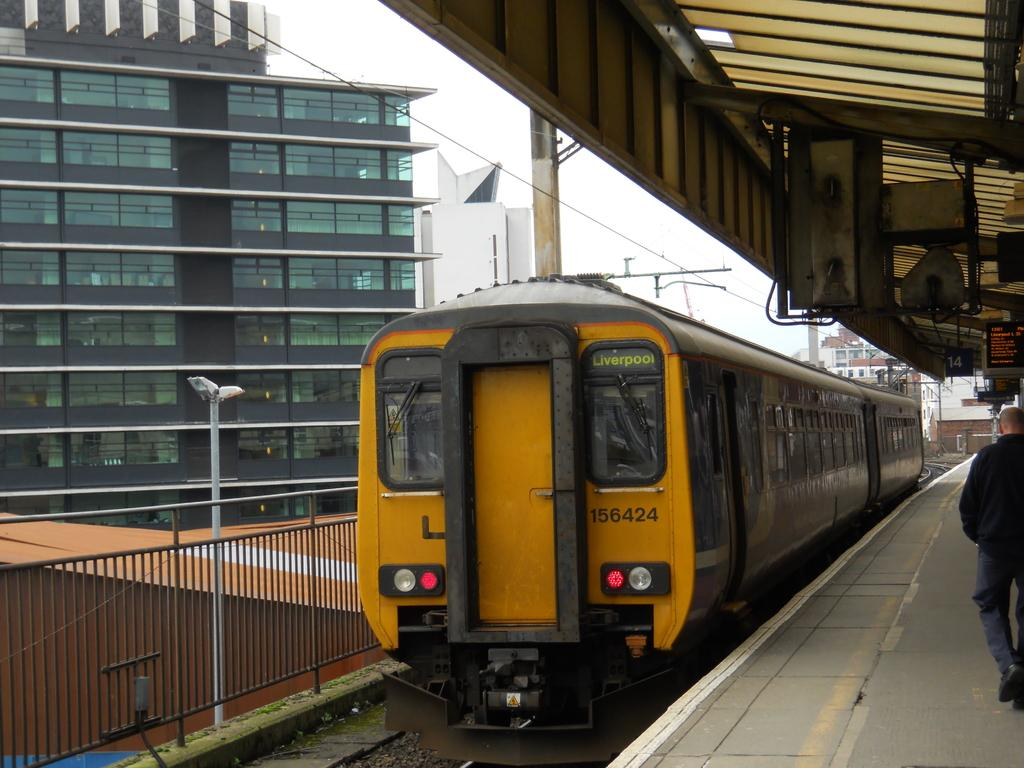What is the main subject of the image? The main subject of the image is a train. What can be seen near the train in the image? There is a platform in the image. Are there any people in the image? Yes, there is a person in the image. What is visible in the background of the image? There are buildings and the sky in the background of the image. What other objects can be seen in the image? There are iron grilles, poles, and lights in the image. What type of feeling can be seen on the person's face in the image? The image does not show the person's face, so it is not possible to determine their feelings. 